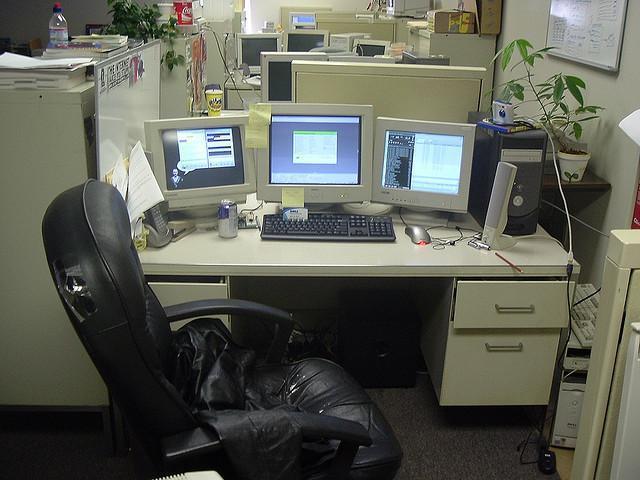How many monitors are there?
Give a very brief answer. 3. How many potted plants can be seen?
Give a very brief answer. 1. How many tvs can be seen?
Give a very brief answer. 3. How many carrots are on the plate?
Give a very brief answer. 0. 